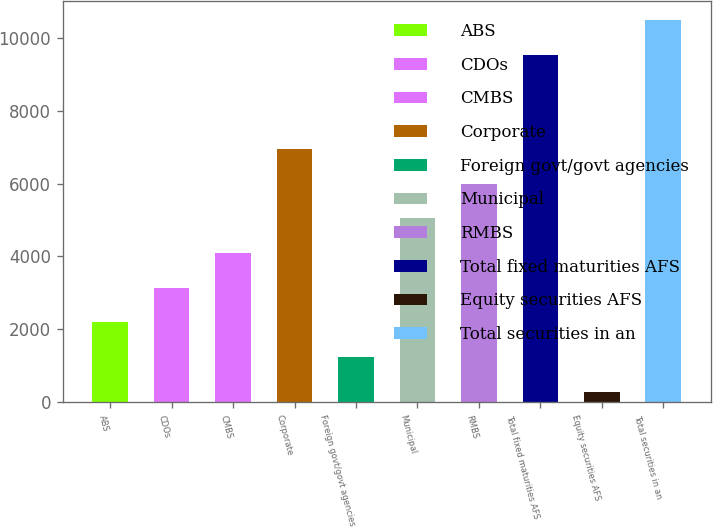<chart> <loc_0><loc_0><loc_500><loc_500><bar_chart><fcel>ABS<fcel>CDOs<fcel>CMBS<fcel>Corporate<fcel>Foreign govt/govt agencies<fcel>Municipal<fcel>RMBS<fcel>Total fixed maturities AFS<fcel>Equity securities AFS<fcel>Total securities in an<nl><fcel>2190.8<fcel>3142.7<fcel>4094.6<fcel>6950.3<fcel>1238.9<fcel>5046.5<fcel>5998.4<fcel>9519<fcel>287<fcel>10470.9<nl></chart> 